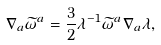<formula> <loc_0><loc_0><loc_500><loc_500>\nabla _ { a } \widetilde { \omega } ^ { a } = \frac { 3 } { 2 } \lambda ^ { - 1 } \widetilde { \omega } ^ { a } \nabla _ { a } \lambda ,</formula> 